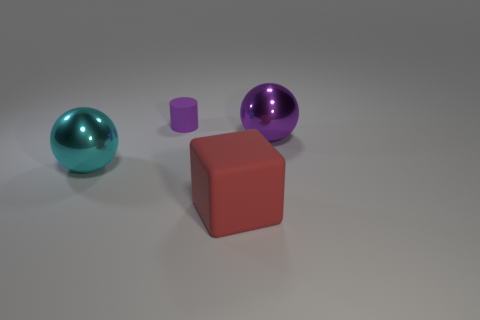Is there a big purple metal sphere that is behind the thing that is in front of the ball that is left of the large purple ball?
Make the answer very short. Yes. What color is the other big thing that is the same shape as the cyan object?
Offer a terse response. Purple. How many cyan things are shiny balls or small blocks?
Give a very brief answer. 1. There is a large thing that is in front of the big sphere that is left of the big cube; what is it made of?
Your response must be concise. Rubber. Does the large purple thing have the same shape as the big cyan thing?
Your answer should be compact. Yes. There is a sphere that is the same size as the purple metallic thing; what is its color?
Offer a very short reply. Cyan. Is there a large thing of the same color as the tiny rubber object?
Give a very brief answer. Yes. Are there any purple shiny blocks?
Your answer should be very brief. No. Do the large sphere on the right side of the large red rubber object and the big cyan thing have the same material?
Give a very brief answer. Yes. What size is the shiny ball that is the same color as the tiny thing?
Provide a succinct answer. Large. 